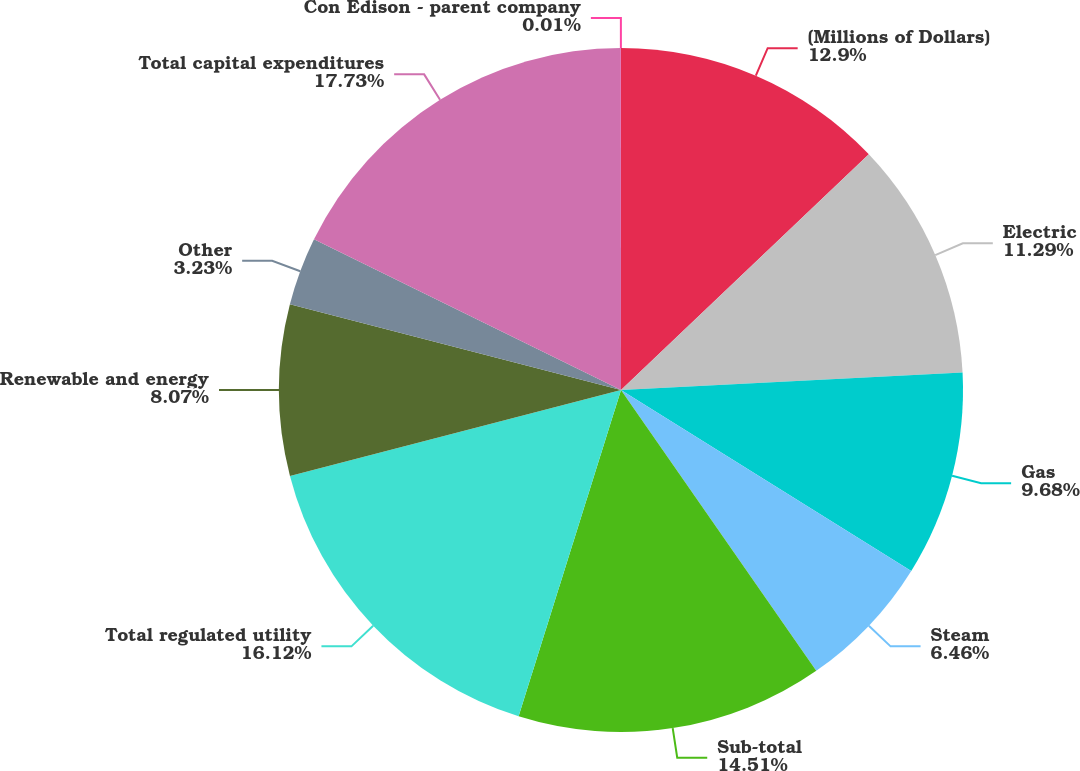<chart> <loc_0><loc_0><loc_500><loc_500><pie_chart><fcel>(Millions of Dollars)<fcel>Electric<fcel>Gas<fcel>Steam<fcel>Sub-total<fcel>Total regulated utility<fcel>Renewable and energy<fcel>Other<fcel>Total capital expenditures<fcel>Con Edison - parent company<nl><fcel>12.9%<fcel>11.29%<fcel>9.68%<fcel>6.46%<fcel>14.51%<fcel>16.12%<fcel>8.07%<fcel>3.23%<fcel>17.73%<fcel>0.01%<nl></chart> 